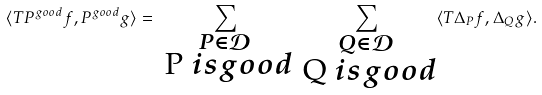Convert formula to latex. <formula><loc_0><loc_0><loc_500><loc_500>\langle T P ^ { g o o d } f , P ^ { g o o d } g \rangle = \sum _ { \substack { P \in \mathcal { D } \\ $ P $ i s g o o d } } \sum _ { \substack { Q \in \mathcal { D } \\ $ Q $ i s g o o d } } \langle T \Delta _ { P } f , \Delta _ { Q } g \rangle .</formula> 